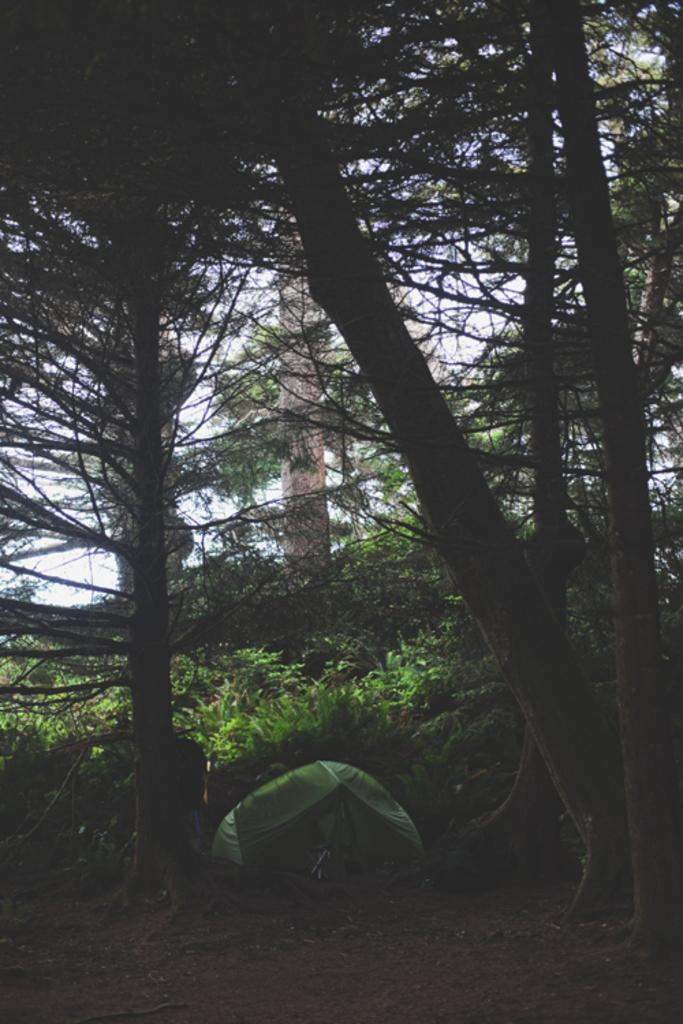What type of vegetation is present in the image? There are many trees in the image. What type of shelter is visible on the ground? There is a green color tent for shelter on the ground. What structure can be seen in the image besides the trees? A tower is visible in the image. What part of the natural environment is visible in the image? The sky is visible in the image. What type of mint is being used for breakfast in the image? There is no mint or breakfast present in the image. 